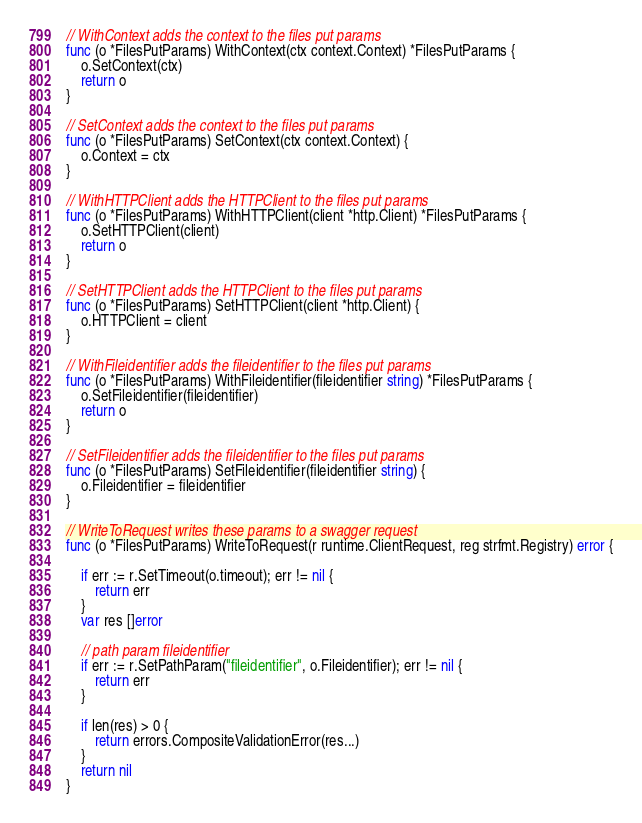<code> <loc_0><loc_0><loc_500><loc_500><_Go_>// WithContext adds the context to the files put params
func (o *FilesPutParams) WithContext(ctx context.Context) *FilesPutParams {
	o.SetContext(ctx)
	return o
}

// SetContext adds the context to the files put params
func (o *FilesPutParams) SetContext(ctx context.Context) {
	o.Context = ctx
}

// WithHTTPClient adds the HTTPClient to the files put params
func (o *FilesPutParams) WithHTTPClient(client *http.Client) *FilesPutParams {
	o.SetHTTPClient(client)
	return o
}

// SetHTTPClient adds the HTTPClient to the files put params
func (o *FilesPutParams) SetHTTPClient(client *http.Client) {
	o.HTTPClient = client
}

// WithFileidentifier adds the fileidentifier to the files put params
func (o *FilesPutParams) WithFileidentifier(fileidentifier string) *FilesPutParams {
	o.SetFileidentifier(fileidentifier)
	return o
}

// SetFileidentifier adds the fileidentifier to the files put params
func (o *FilesPutParams) SetFileidentifier(fileidentifier string) {
	o.Fileidentifier = fileidentifier
}

// WriteToRequest writes these params to a swagger request
func (o *FilesPutParams) WriteToRequest(r runtime.ClientRequest, reg strfmt.Registry) error {

	if err := r.SetTimeout(o.timeout); err != nil {
		return err
	}
	var res []error

	// path param fileidentifier
	if err := r.SetPathParam("fileidentifier", o.Fileidentifier); err != nil {
		return err
	}

	if len(res) > 0 {
		return errors.CompositeValidationError(res...)
	}
	return nil
}
</code> 